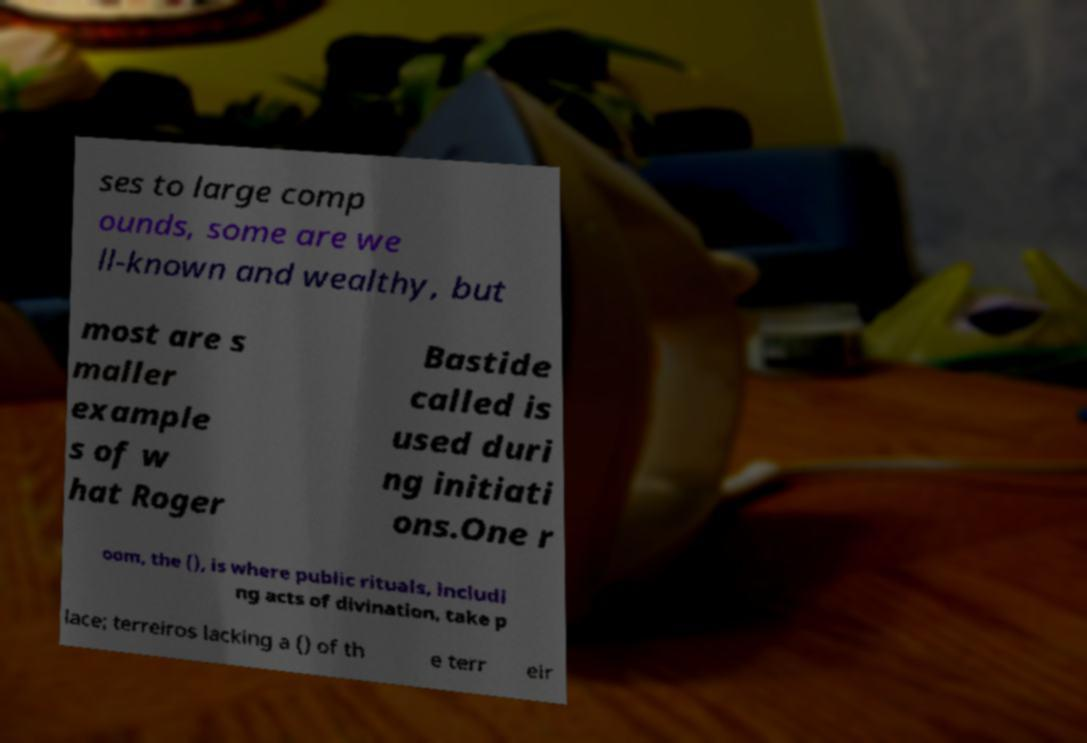What messages or text are displayed in this image? I need them in a readable, typed format. ses to large comp ounds, some are we ll-known and wealthy, but most are s maller example s of w hat Roger Bastide called is used duri ng initiati ons.One r oom, the (), is where public rituals, includi ng acts of divination, take p lace; terreiros lacking a () of th e terr eir 